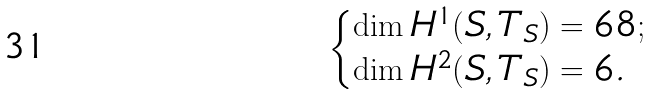<formula> <loc_0><loc_0><loc_500><loc_500>\begin{cases} \dim H ^ { 1 } ( S , T _ { S } ) = 6 8 ; \\ \dim H ^ { 2 } ( S , T _ { S } ) = 6 . \end{cases}</formula> 